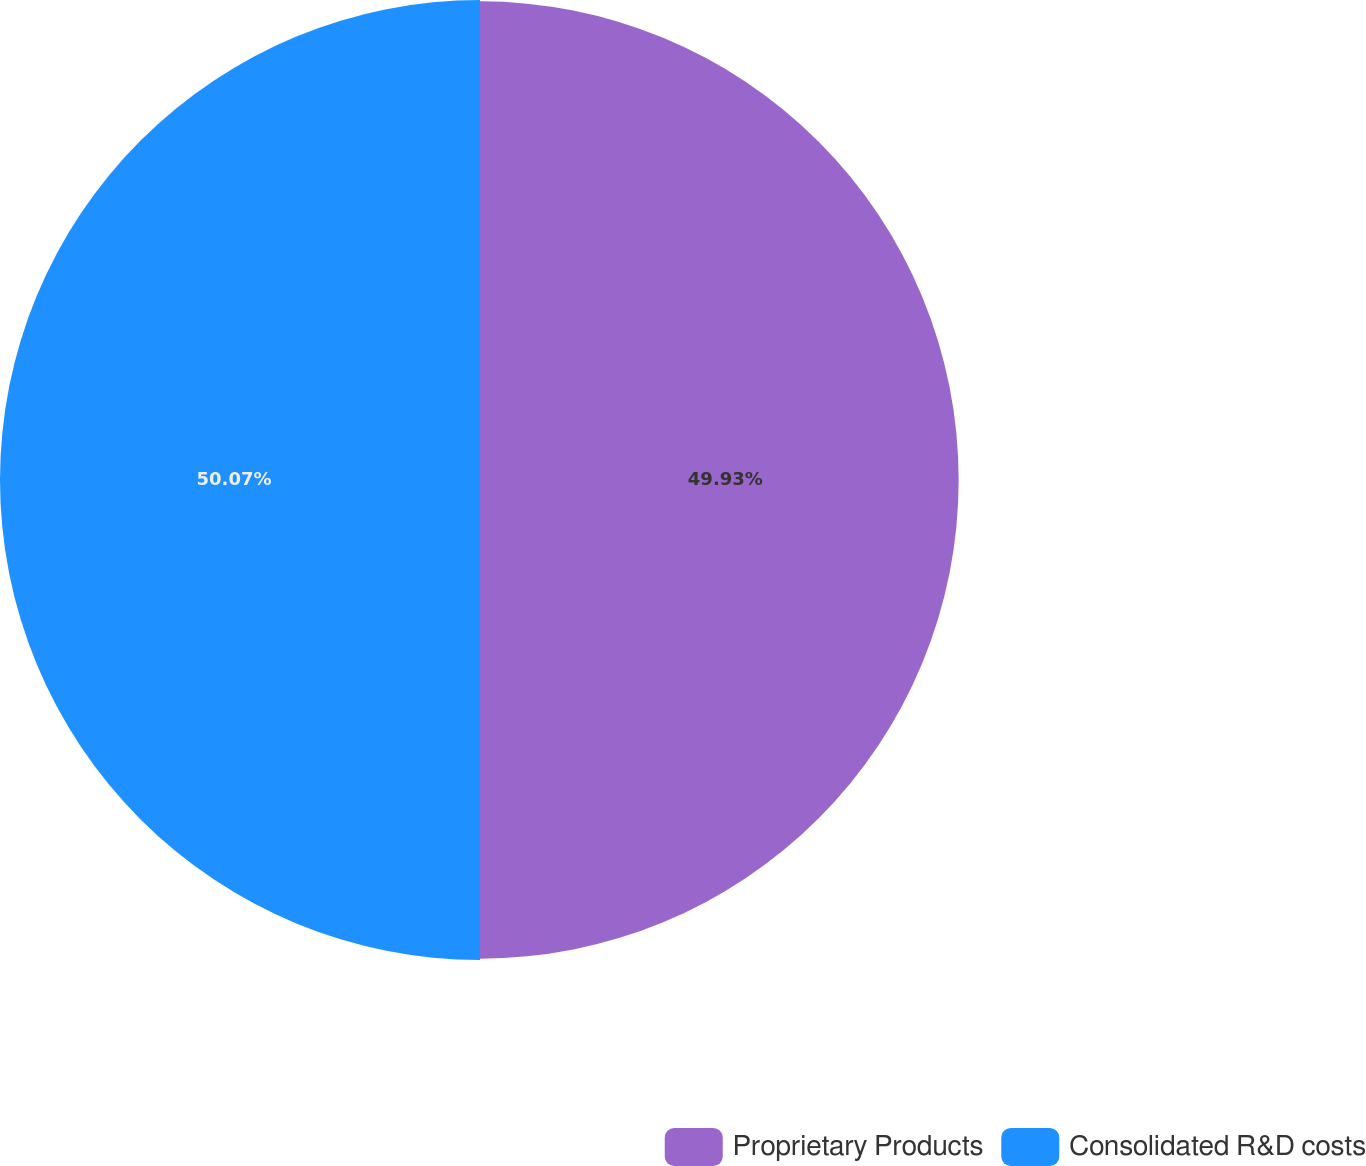<chart> <loc_0><loc_0><loc_500><loc_500><pie_chart><fcel>Proprietary Products<fcel>Consolidated R&D costs<nl><fcel>49.93%<fcel>50.07%<nl></chart> 